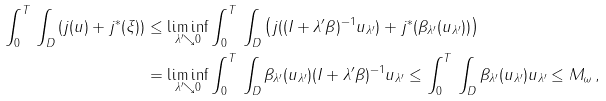<formula> <loc_0><loc_0><loc_500><loc_500>\int _ { 0 } ^ { T } \, \int _ { D } \left ( j ( u ) + j ^ { * } ( \xi ) \right ) & \leq \liminf _ { \lambda ^ { \prime } \searrow 0 } \int _ { 0 } ^ { T } \, \int _ { D } \left ( j ( ( I + \lambda ^ { \prime } \beta ) ^ { - 1 } u _ { \lambda ^ { \prime } } ) + j ^ { * } ( \beta _ { \lambda ^ { \prime } } ( u _ { \lambda ^ { \prime } } ) ) \right ) \\ & = \liminf _ { \lambda ^ { \prime } \searrow 0 } \int _ { 0 } ^ { T } \, \int _ { D } \beta _ { \lambda ^ { \prime } } ( u _ { \lambda ^ { \prime } } ) ( I + \lambda ^ { \prime } \beta ) ^ { - 1 } u _ { \lambda ^ { \prime } } \leq \int _ { 0 } ^ { T } \, \int _ { D } \beta _ { \lambda ^ { \prime } } ( u _ { \lambda ^ { \prime } } ) u _ { \lambda ^ { \prime } } \leq M _ { \omega } \, ,</formula> 